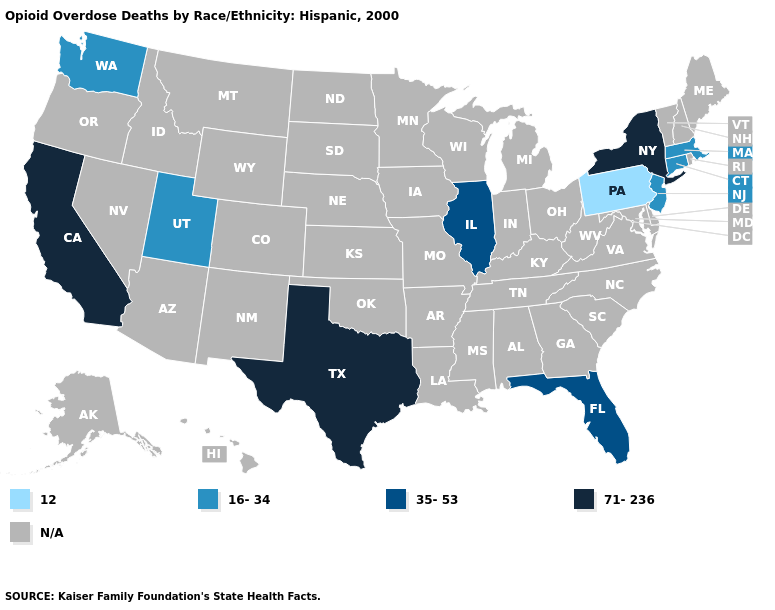What is the lowest value in the USA?
Keep it brief. 12. What is the highest value in the USA?
Short answer required. 71-236. What is the highest value in the USA?
Write a very short answer. 71-236. What is the value of Kansas?
Write a very short answer. N/A. Name the states that have a value in the range N/A?
Short answer required. Alabama, Alaska, Arizona, Arkansas, Colorado, Delaware, Georgia, Hawaii, Idaho, Indiana, Iowa, Kansas, Kentucky, Louisiana, Maine, Maryland, Michigan, Minnesota, Mississippi, Missouri, Montana, Nebraska, Nevada, New Hampshire, New Mexico, North Carolina, North Dakota, Ohio, Oklahoma, Oregon, Rhode Island, South Carolina, South Dakota, Tennessee, Vermont, Virginia, West Virginia, Wisconsin, Wyoming. Does Florida have the highest value in the USA?
Write a very short answer. No. Among the states that border New Jersey , does New York have the lowest value?
Quick response, please. No. What is the value of Illinois?
Answer briefly. 35-53. Does the map have missing data?
Concise answer only. Yes. What is the value of Massachusetts?
Concise answer only. 16-34. What is the value of Alabama?
Concise answer only. N/A. Which states hav the highest value in the West?
Keep it brief. California. What is the value of Michigan?
Answer briefly. N/A. 